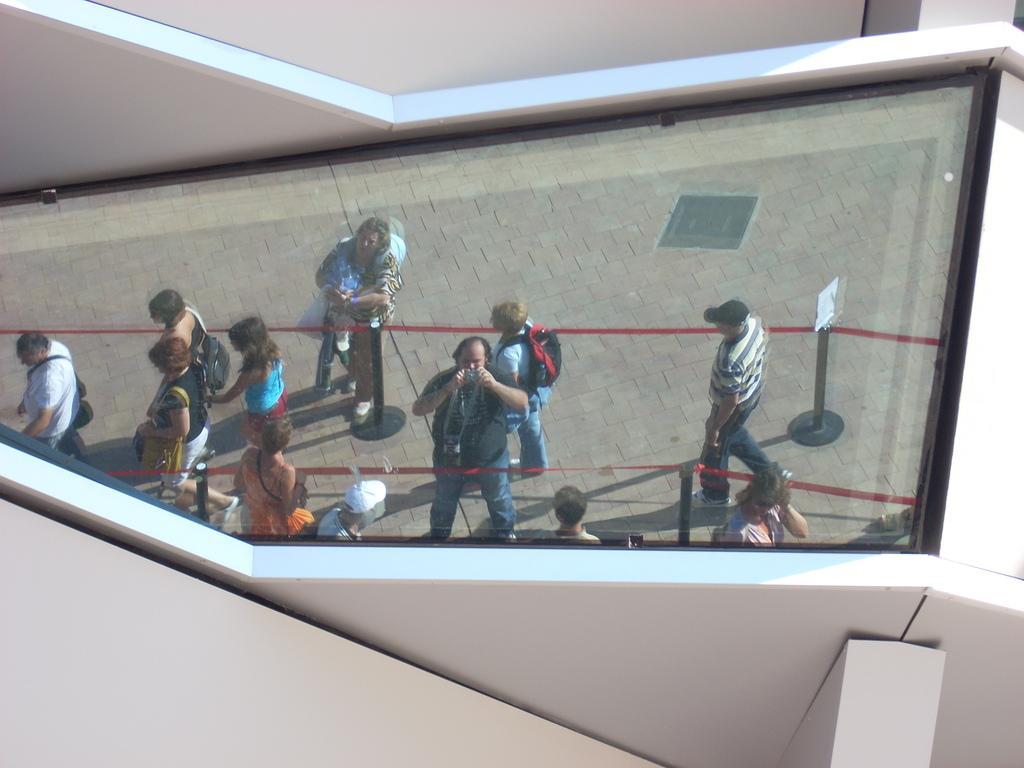Can you describe this image briefly? In this image we can see the glass window and through the glass window we can see the people and also the barrier rods with the ribbon. We can also see the path and also the walls. 